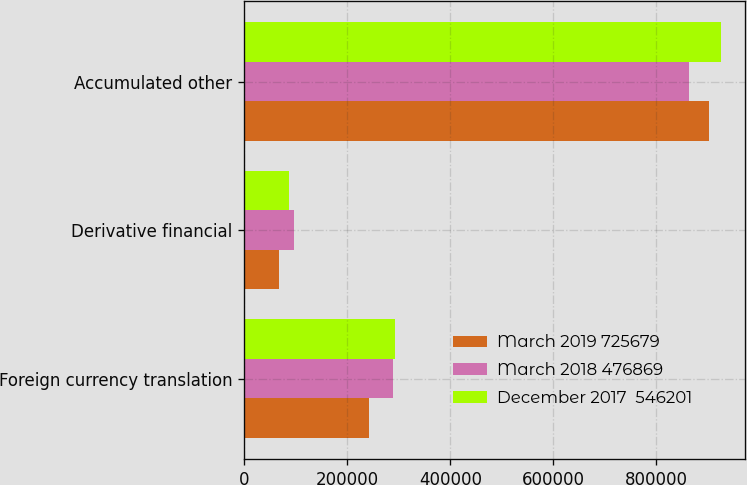<chart> <loc_0><loc_0><loc_500><loc_500><stacked_bar_chart><ecel><fcel>Foreign currency translation<fcel>Derivative financial<fcel>Accumulated other<nl><fcel>March 2019 725679<fcel>243184<fcel>66788<fcel>902075<nl><fcel>March 2018 476869<fcel>289618<fcel>97543<fcel>864030<nl><fcel>December 2017  546201<fcel>291949<fcel>87990<fcel>926140<nl></chart> 